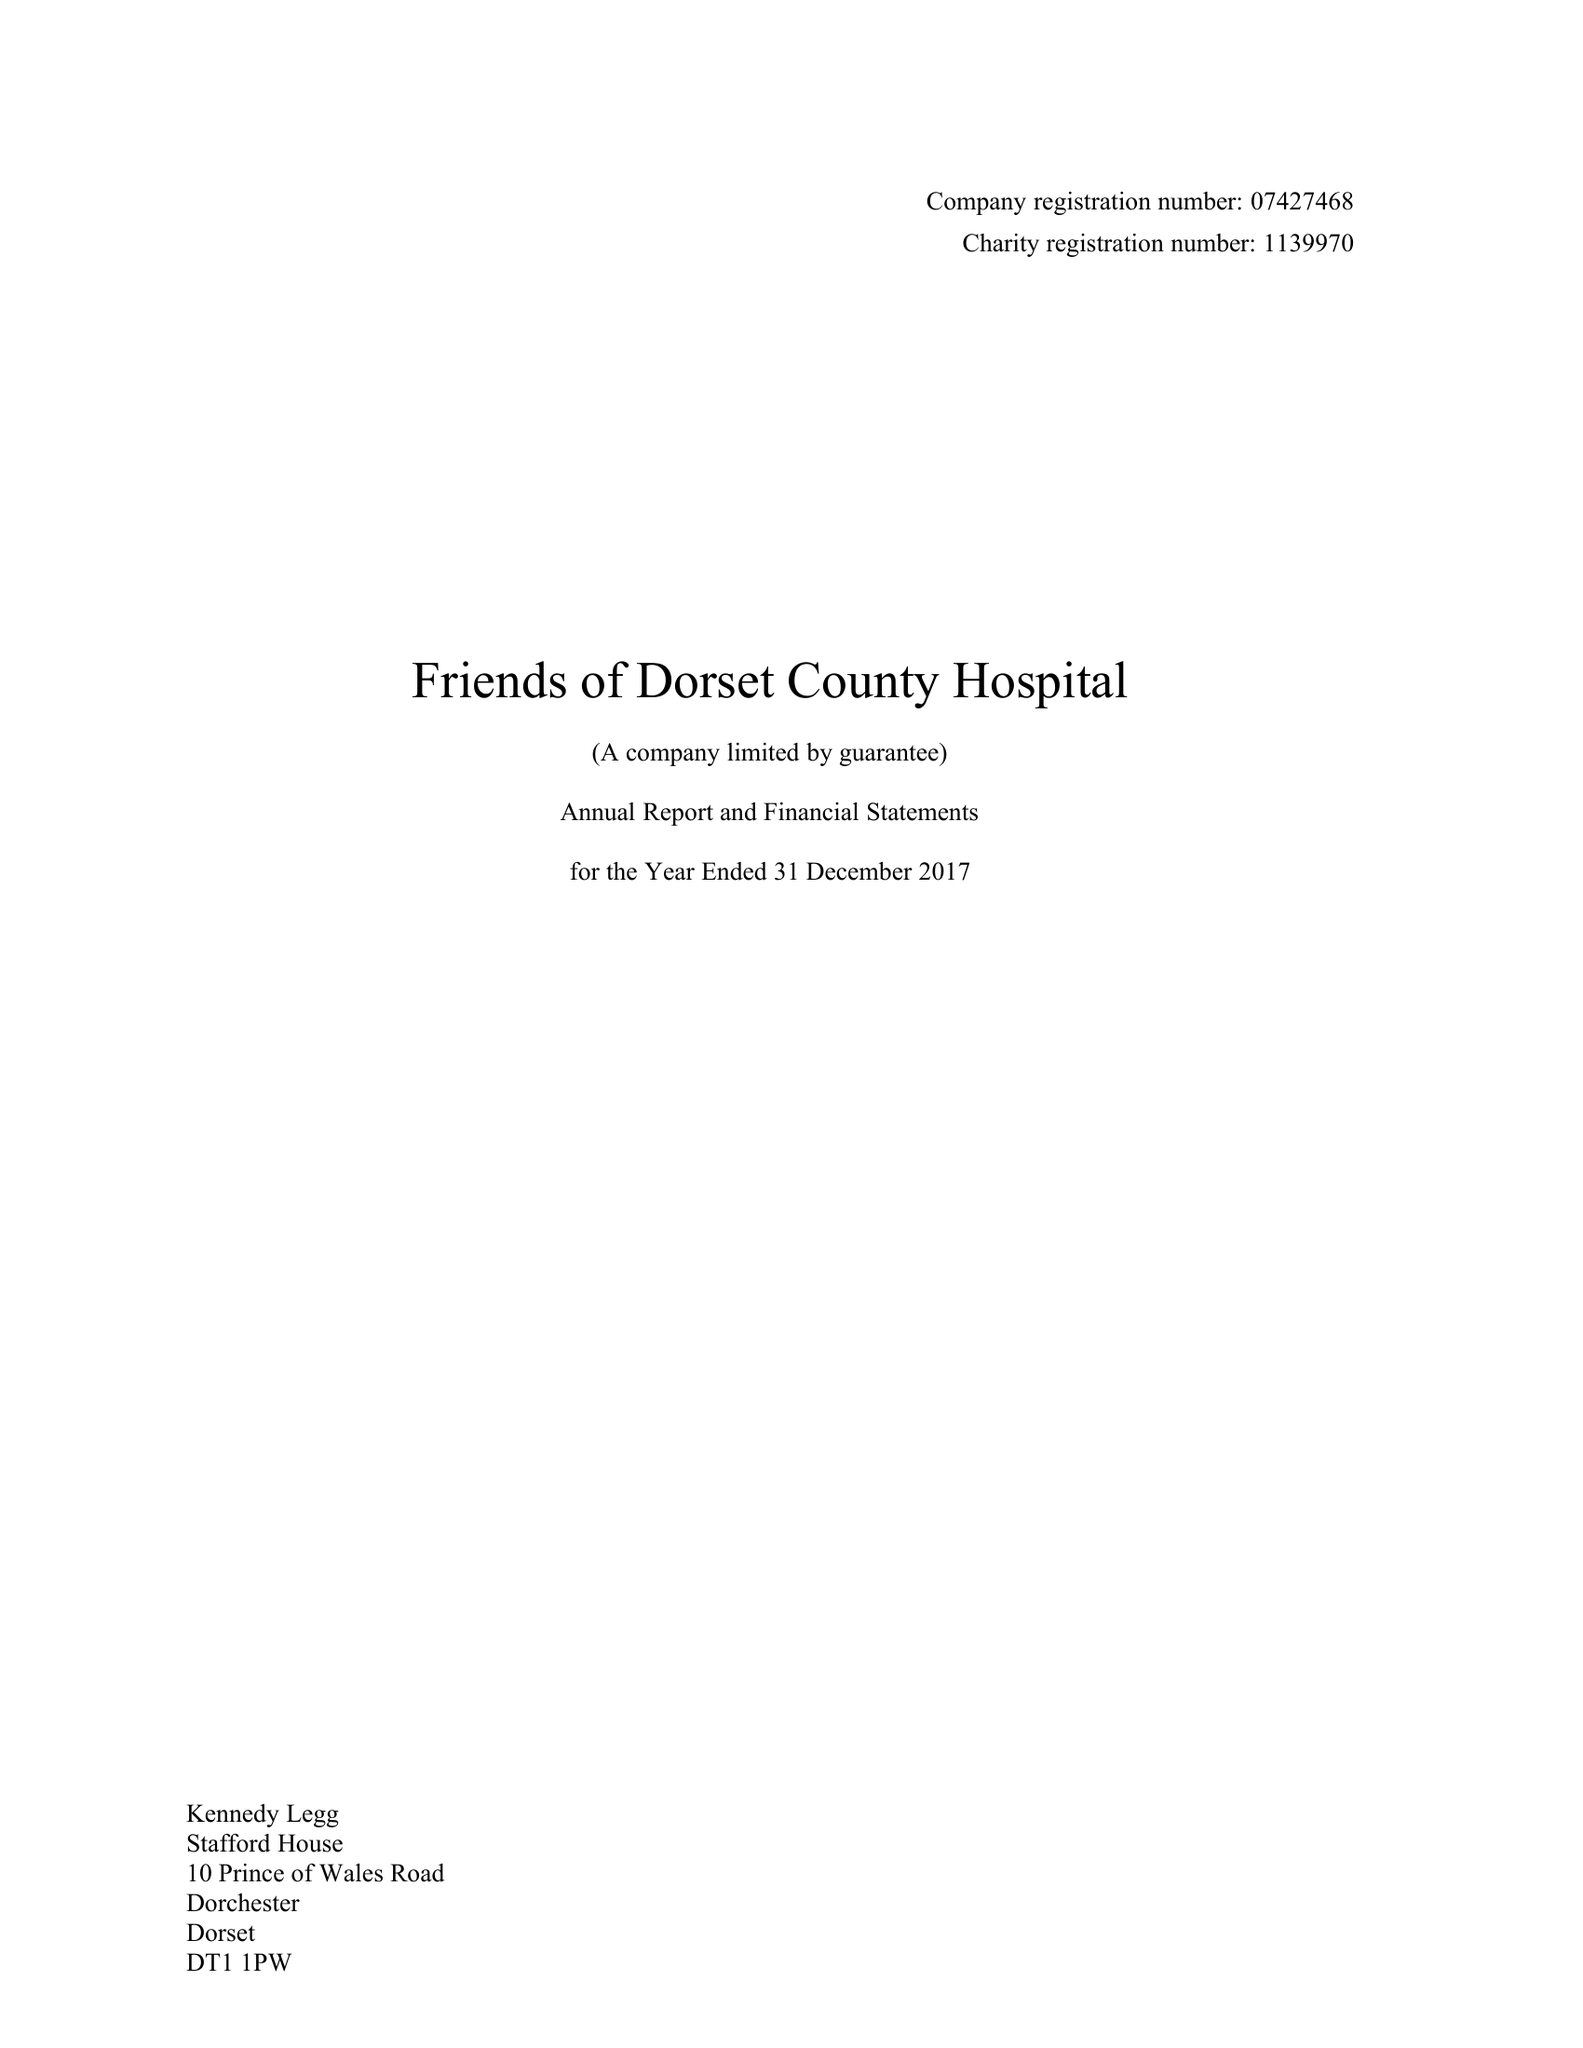What is the value for the spending_annually_in_british_pounds?
Answer the question using a single word or phrase. 138485.00 